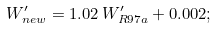<formula> <loc_0><loc_0><loc_500><loc_500>W ^ { \prime } _ { n e w } = 1 . 0 2 \, W ^ { \prime } _ { R 9 7 a } + 0 . 0 0 2 ;</formula> 